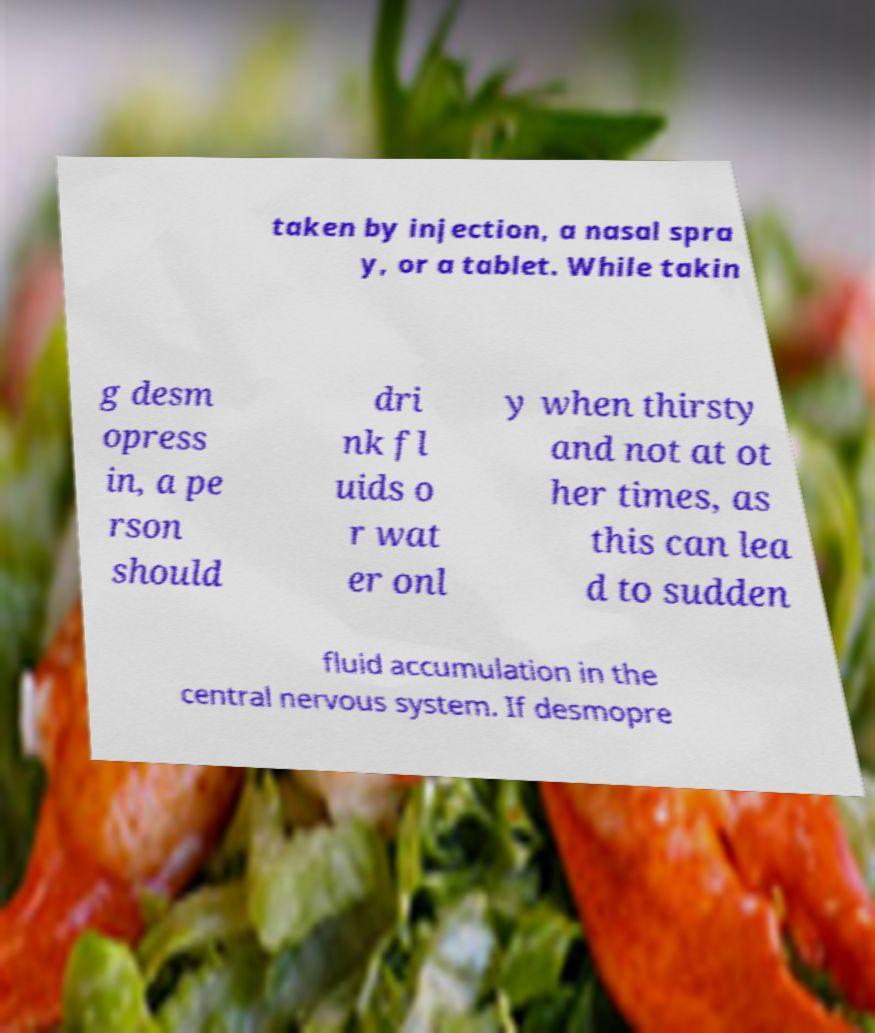For documentation purposes, I need the text within this image transcribed. Could you provide that? taken by injection, a nasal spra y, or a tablet. While takin g desm opress in, a pe rson should dri nk fl uids o r wat er onl y when thirsty and not at ot her times, as this can lea d to sudden fluid accumulation in the central nervous system. If desmopre 